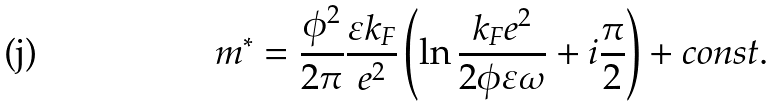Convert formula to latex. <formula><loc_0><loc_0><loc_500><loc_500>m ^ { * } = \frac { \phi ^ { 2 } } { 2 \pi } \frac { \varepsilon k _ { F } } { e ^ { 2 } } \left ( \ln \frac { k _ { F } e ^ { 2 } } { 2 \phi \varepsilon \omega } + i \frac { \pi } { 2 } \right ) + c o n s t .</formula> 